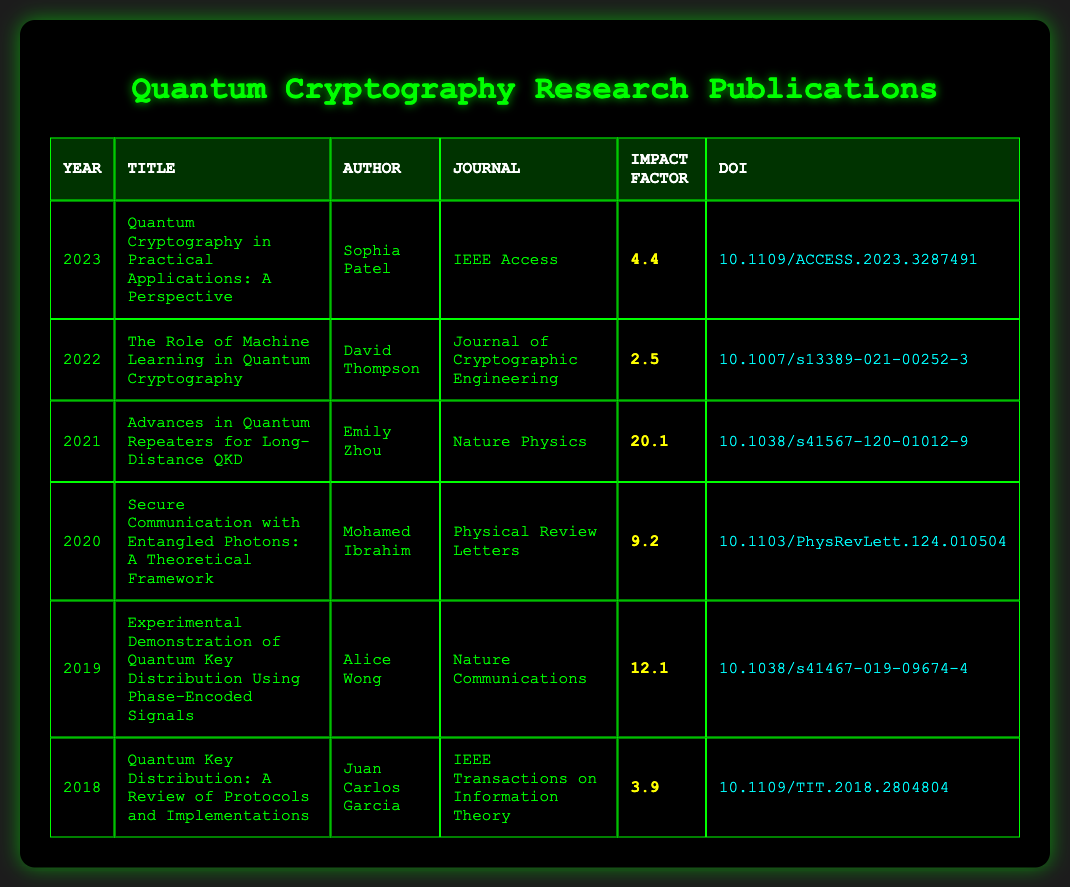What is the impact factor of the publication in 2021? The table shows that the publication for 2021 is titled "Advances in Quantum Repeaters for Long-Distance QKD," and its impact factor is listed as 20.1.
Answer: 20.1 Who is the author of the publication from 2022? The publication titled "The Role of Machine Learning in Quantum Cryptography" from the year 2022 is authored by David Thompson.
Answer: David Thompson Which year has the highest impact factor, and what is that figure? By examining the impact factors listed, 2021 has the highest impact factor of 20.1 compared to all other years shown in the table.
Answer: 2021, 20.1 What is the average impact factor for the publications listed in the table from 2018 to 2023? The impact factors from these years are 3.9, 12.1, 9.2, 20.1, 2.5, and 4.4. Adding these gives 52.2. There are 6 data points, so averaging would be 52.2 / 6 = 8.7.
Answer: 8.7 Is there a publication in the table from the journal "Nature Physics"? Yes, the publication titled "Advances in Quantum Repeaters for Long-Distance QKD" in 2021 is from the journal "Nature Physics."
Answer: Yes What is the difference in impact factor between the highest (2021) and lowest (2022) impact factors? The impact factor for 2021 is 20.1, and for 2022 it is 2.5. The difference is calculated as 20.1 - 2.5 = 17.6.
Answer: 17.6 How many publications listed have an impact factor greater than 10? Looking at the impact factors, only the years 2019 (12.1) and 2021 (20.1) have impact factors greater than 10. Therefore, there are 2 publications that meet this criterion.
Answer: 2 Which publication has the DOI ending with 504? The publication titled "Secure Communication with Entangled Photons: A Theoretical Framework" from 2020 has the DOI that ends with 504, specifically "10.1103/PhysRevLett.124.010504."
Answer: Secure Communication with Entangled Photons: A Theoretical Framework What is the trend in impact factors from 2018 to 2023? Examining the impact factors from the years provided: they are 3.9 (2018), 12.1 (2019), 9.2 (2020), 20.1 (2021), 2.5 (2022), and 4.4 (2023). Overall, the trend starts low in 2018, peaks in 2021, then drops again in 2022 and 2023.
Answer: Peaks in 2021, then declines 